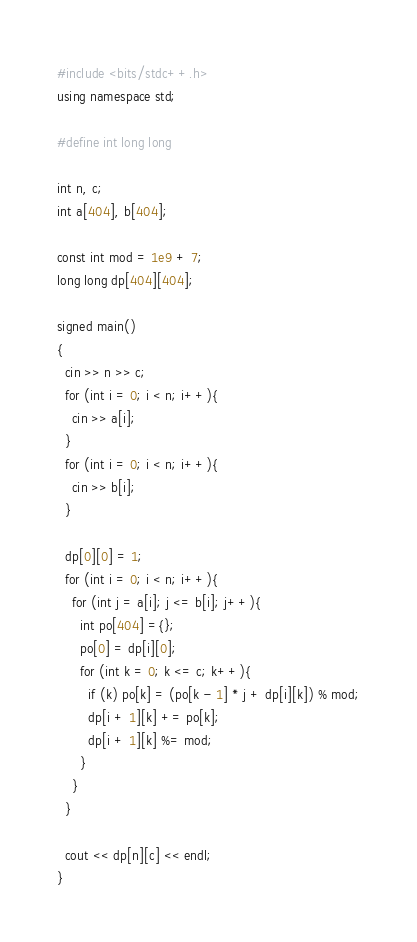<code> <loc_0><loc_0><loc_500><loc_500><_C++_>#include <bits/stdc++.h>
using namespace std;

#define int long long

int n, c;
int a[404], b[404];

const int mod = 1e9 + 7;
long long dp[404][404];

signed main()
{
  cin >> n >> c;
  for (int i = 0; i < n; i++){
    cin >> a[i];
  }
  for (int i = 0; i < n; i++){
    cin >> b[i];
  }

  dp[0][0] = 1;
  for (int i = 0; i < n; i++){
    for (int j = a[i]; j <= b[i]; j++){
      int po[404] ={};
      po[0] = dp[i][0];
      for (int k = 0; k <= c; k++){
        if (k) po[k] = (po[k - 1] * j + dp[i][k]) % mod;
        dp[i + 1][k] += po[k];
        dp[i + 1][k] %= mod;
      }
    }
  }

  cout << dp[n][c] << endl;
}
</code> 